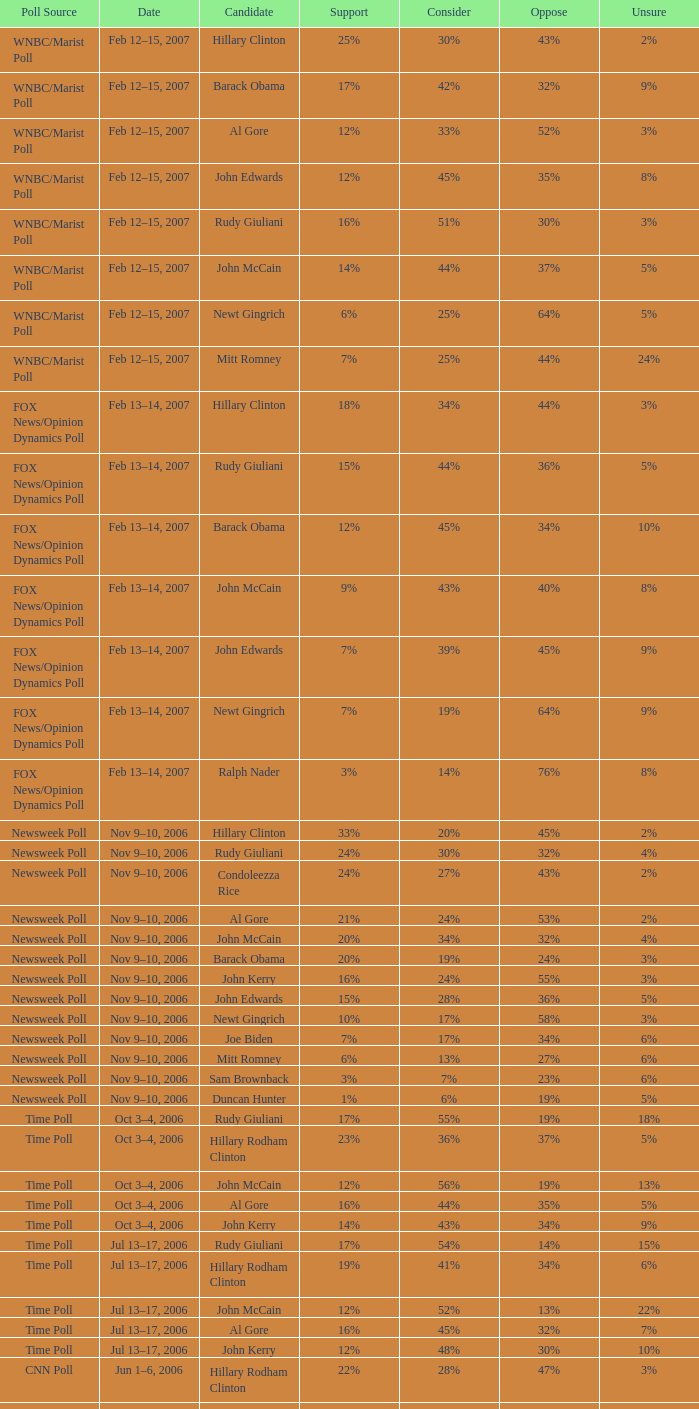What fraction of people disapproved of the candidate as per the time poll poll which revealed 6% of persons were in doubt? 34%. 